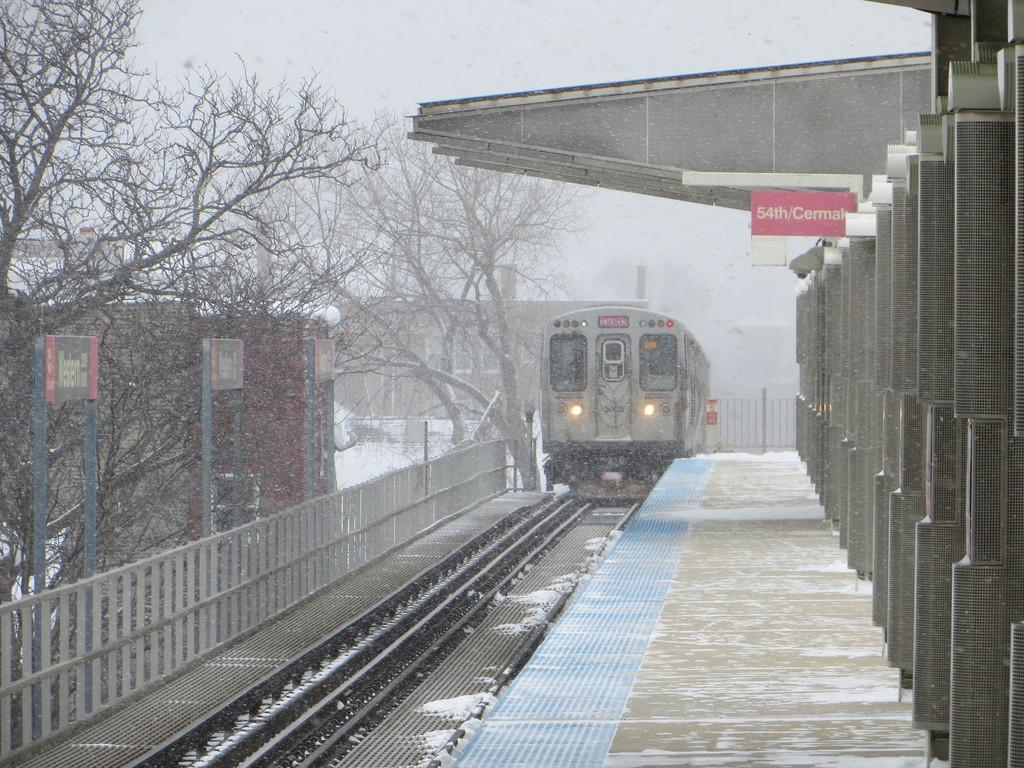<image>
Create a compact narrative representing the image presented. The train rides into snowy train station in the dead of winter. 